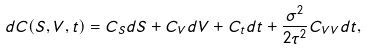Convert formula to latex. <formula><loc_0><loc_0><loc_500><loc_500>d C ( S , V , t ) = C _ { S } d S + C _ { V } d V + C _ { t } d t + \frac { \sigma ^ { 2 } } { 2 \tau ^ { 2 } } C _ { V V } d t ,</formula> 